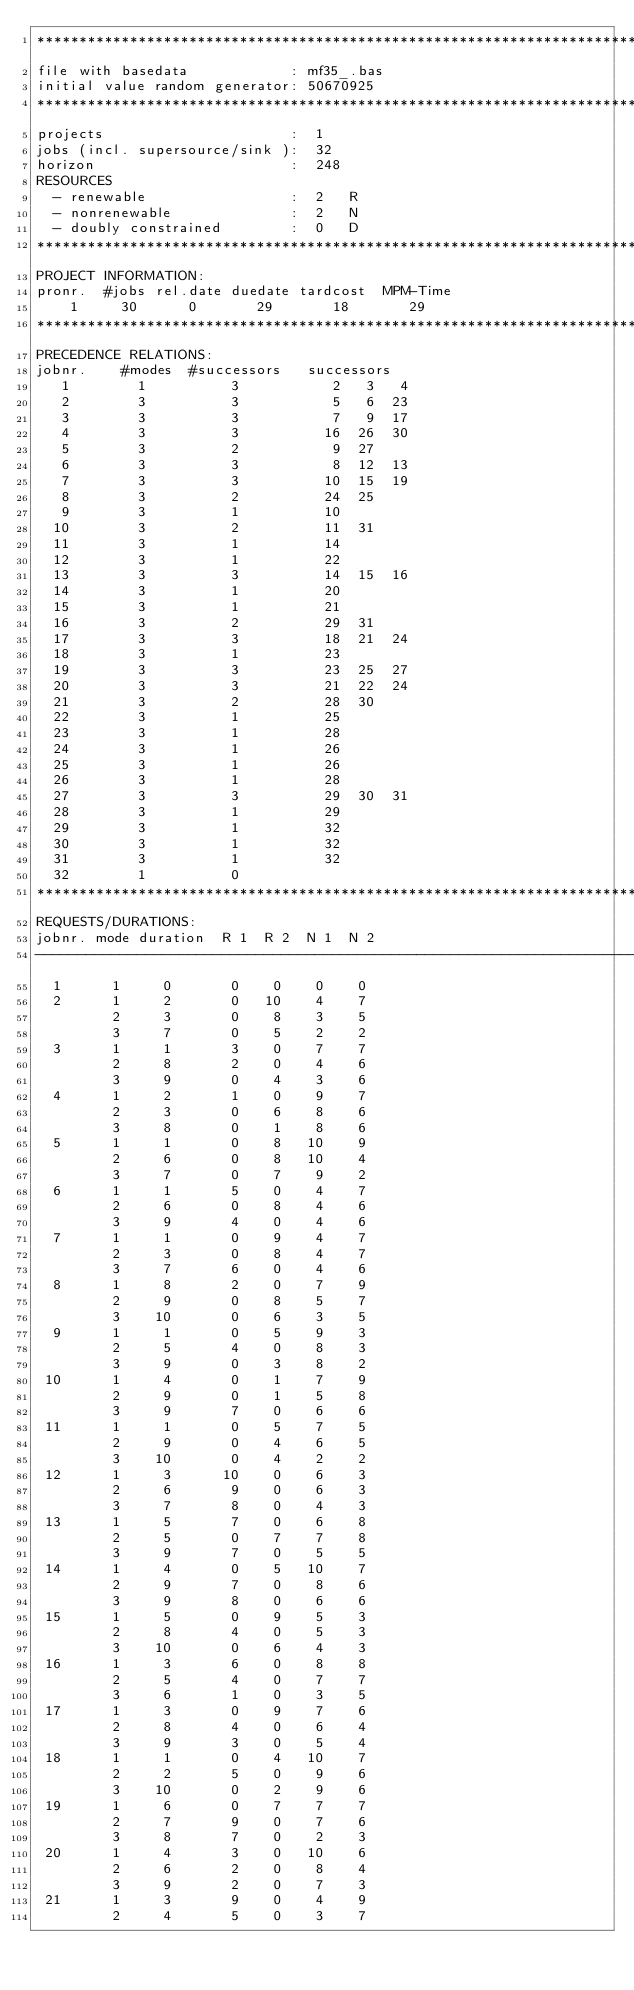Convert code to text. <code><loc_0><loc_0><loc_500><loc_500><_ObjectiveC_>************************************************************************
file with basedata            : mf35_.bas
initial value random generator: 50670925
************************************************************************
projects                      :  1
jobs (incl. supersource/sink ):  32
horizon                       :  248
RESOURCES
  - renewable                 :  2   R
  - nonrenewable              :  2   N
  - doubly constrained        :  0   D
************************************************************************
PROJECT INFORMATION:
pronr.  #jobs rel.date duedate tardcost  MPM-Time
    1     30      0       29       18       29
************************************************************************
PRECEDENCE RELATIONS:
jobnr.    #modes  #successors   successors
   1        1          3           2   3   4
   2        3          3           5   6  23
   3        3          3           7   9  17
   4        3          3          16  26  30
   5        3          2           9  27
   6        3          3           8  12  13
   7        3          3          10  15  19
   8        3          2          24  25
   9        3          1          10
  10        3          2          11  31
  11        3          1          14
  12        3          1          22
  13        3          3          14  15  16
  14        3          1          20
  15        3          1          21
  16        3          2          29  31
  17        3          3          18  21  24
  18        3          1          23
  19        3          3          23  25  27
  20        3          3          21  22  24
  21        3          2          28  30
  22        3          1          25
  23        3          1          28
  24        3          1          26
  25        3          1          26
  26        3          1          28
  27        3          3          29  30  31
  28        3          1          29
  29        3          1          32
  30        3          1          32
  31        3          1          32
  32        1          0        
************************************************************************
REQUESTS/DURATIONS:
jobnr. mode duration  R 1  R 2  N 1  N 2
------------------------------------------------------------------------
  1      1     0       0    0    0    0
  2      1     2       0   10    4    7
         2     3       0    8    3    5
         3     7       0    5    2    2
  3      1     1       3    0    7    7
         2     8       2    0    4    6
         3     9       0    4    3    6
  4      1     2       1    0    9    7
         2     3       0    6    8    6
         3     8       0    1    8    6
  5      1     1       0    8   10    9
         2     6       0    8   10    4
         3     7       0    7    9    2
  6      1     1       5    0    4    7
         2     6       0    8    4    6
         3     9       4    0    4    6
  7      1     1       0    9    4    7
         2     3       0    8    4    7
         3     7       6    0    4    6
  8      1     8       2    0    7    9
         2     9       0    8    5    7
         3    10       0    6    3    5
  9      1     1       0    5    9    3
         2     5       4    0    8    3
         3     9       0    3    8    2
 10      1     4       0    1    7    9
         2     9       0    1    5    8
         3     9       7    0    6    6
 11      1     1       0    5    7    5
         2     9       0    4    6    5
         3    10       0    4    2    2
 12      1     3      10    0    6    3
         2     6       9    0    6    3
         3     7       8    0    4    3
 13      1     5       7    0    6    8
         2     5       0    7    7    8
         3     9       7    0    5    5
 14      1     4       0    5   10    7
         2     9       7    0    8    6
         3     9       8    0    6    6
 15      1     5       0    9    5    3
         2     8       4    0    5    3
         3    10       0    6    4    3
 16      1     3       6    0    8    8
         2     5       4    0    7    7
         3     6       1    0    3    5
 17      1     3       0    9    7    6
         2     8       4    0    6    4
         3     9       3    0    5    4
 18      1     1       0    4   10    7
         2     2       5    0    9    6
         3    10       0    2    9    6
 19      1     6       0    7    7    7
         2     7       9    0    7    6
         3     8       7    0    2    3
 20      1     4       3    0   10    6
         2     6       2    0    8    4
         3     9       2    0    7    3
 21      1     3       9    0    4    9
         2     4       5    0    3    7</code> 